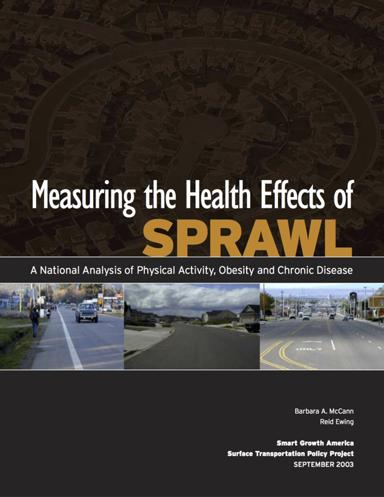When was this brochure published? The brochure was launched in September 2003, a time when the topics of urban planning, obesity, and chronic illness were beginning to receive substantial attention both in public and academic spheres. 